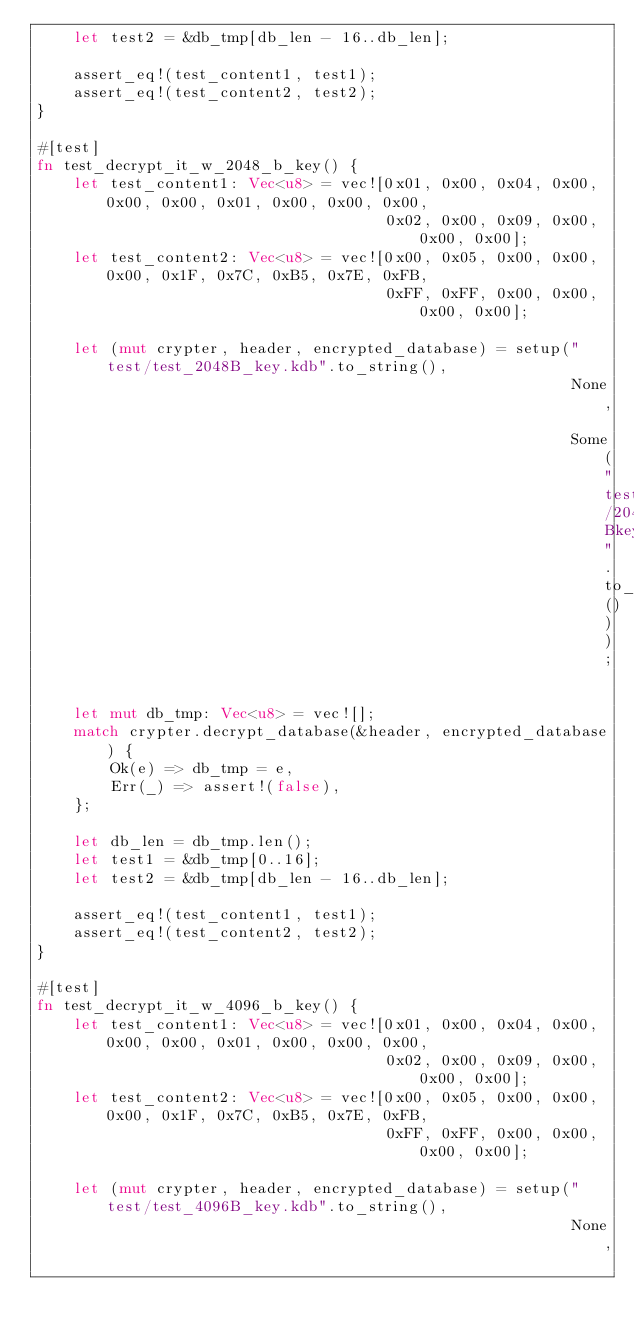Convert code to text. <code><loc_0><loc_0><loc_500><loc_500><_Rust_>    let test2 = &db_tmp[db_len - 16..db_len];

    assert_eq!(test_content1, test1);
    assert_eq!(test_content2, test2);
}

#[test]
fn test_decrypt_it_w_2048_b_key() {
    let test_content1: Vec<u8> = vec![0x01, 0x00, 0x04, 0x00, 0x00, 0x00, 0x01, 0x00, 0x00, 0x00,
                                      0x02, 0x00, 0x09, 0x00, 0x00, 0x00];
    let test_content2: Vec<u8> = vec![0x00, 0x05, 0x00, 0x00, 0x00, 0x1F, 0x7C, 0xB5, 0x7E, 0xFB,
                                      0xFF, 0xFF, 0x00, 0x00, 0x00, 0x00];

    let (mut crypter, header, encrypted_database) = setup("test/test_2048B_key.kdb".to_string(),
                                                          None,
                                                          Some("test/2048Bkey".to_string()));

    let mut db_tmp: Vec<u8> = vec![];
    match crypter.decrypt_database(&header, encrypted_database) {
        Ok(e) => db_tmp = e,
        Err(_) => assert!(false),
    };

    let db_len = db_tmp.len();
    let test1 = &db_tmp[0..16];
    let test2 = &db_tmp[db_len - 16..db_len];

    assert_eq!(test_content1, test1);
    assert_eq!(test_content2, test2);
}

#[test]
fn test_decrypt_it_w_4096_b_key() {
    let test_content1: Vec<u8> = vec![0x01, 0x00, 0x04, 0x00, 0x00, 0x00, 0x01, 0x00, 0x00, 0x00,
                                      0x02, 0x00, 0x09, 0x00, 0x00, 0x00];
    let test_content2: Vec<u8> = vec![0x00, 0x05, 0x00, 0x00, 0x00, 0x1F, 0x7C, 0xB5, 0x7E, 0xFB,
                                      0xFF, 0xFF, 0x00, 0x00, 0x00, 0x00];

    let (mut crypter, header, encrypted_database) = setup("test/test_4096B_key.kdb".to_string(),
                                                          None,</code> 